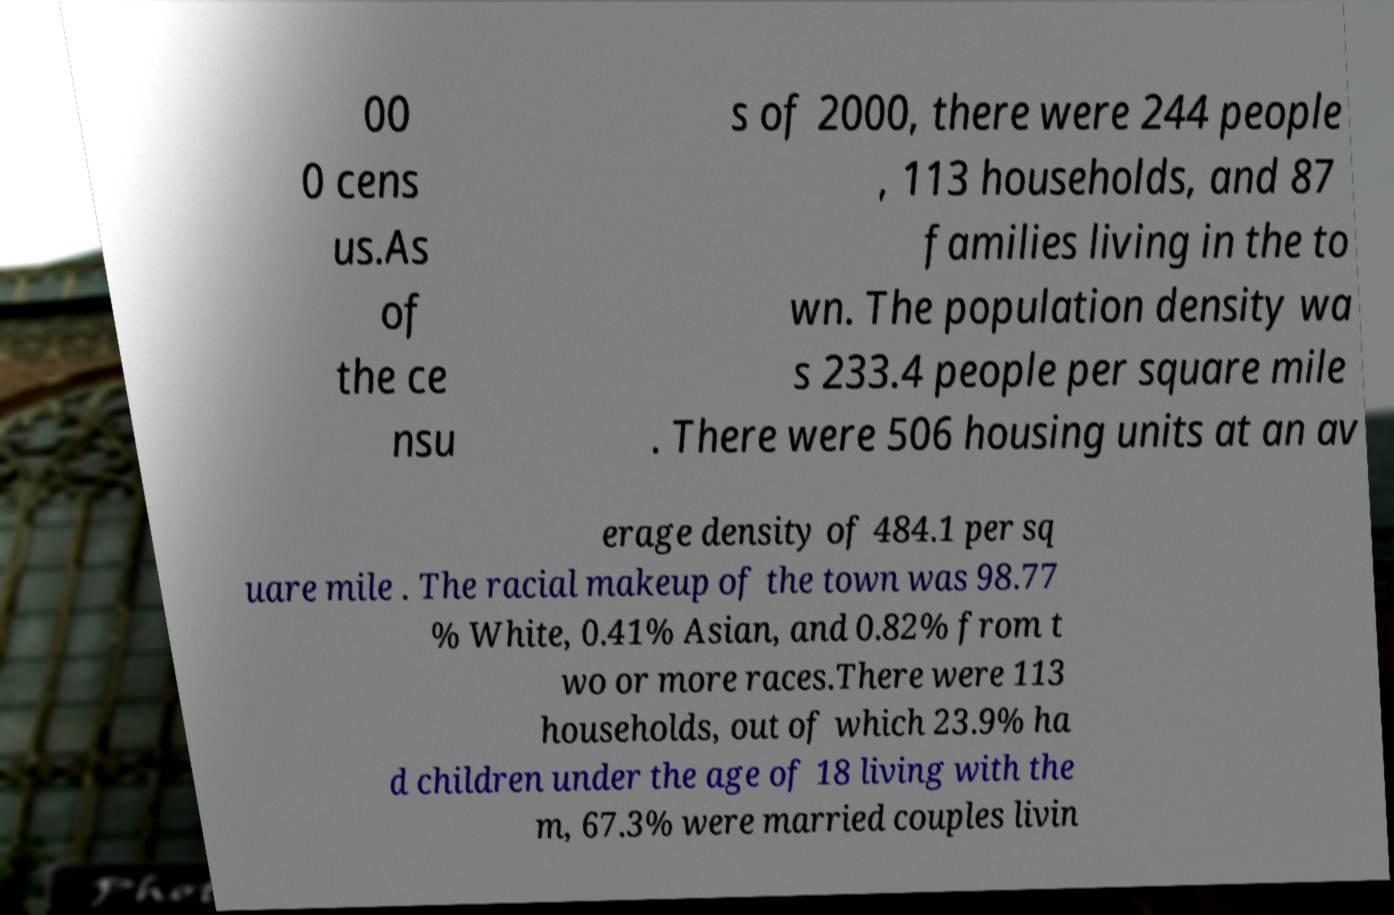Could you assist in decoding the text presented in this image and type it out clearly? 00 0 cens us.As of the ce nsu s of 2000, there were 244 people , 113 households, and 87 families living in the to wn. The population density wa s 233.4 people per square mile . There were 506 housing units at an av erage density of 484.1 per sq uare mile . The racial makeup of the town was 98.77 % White, 0.41% Asian, and 0.82% from t wo or more races.There were 113 households, out of which 23.9% ha d children under the age of 18 living with the m, 67.3% were married couples livin 